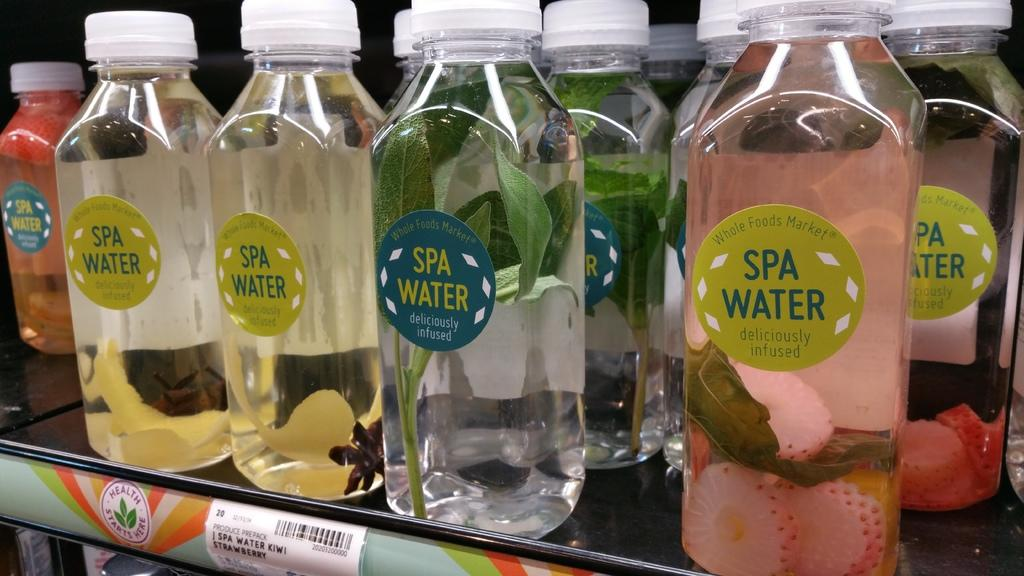<image>
Create a compact narrative representing the image presented. The supermarket shelf contain a selection of Spa Water beverages. 